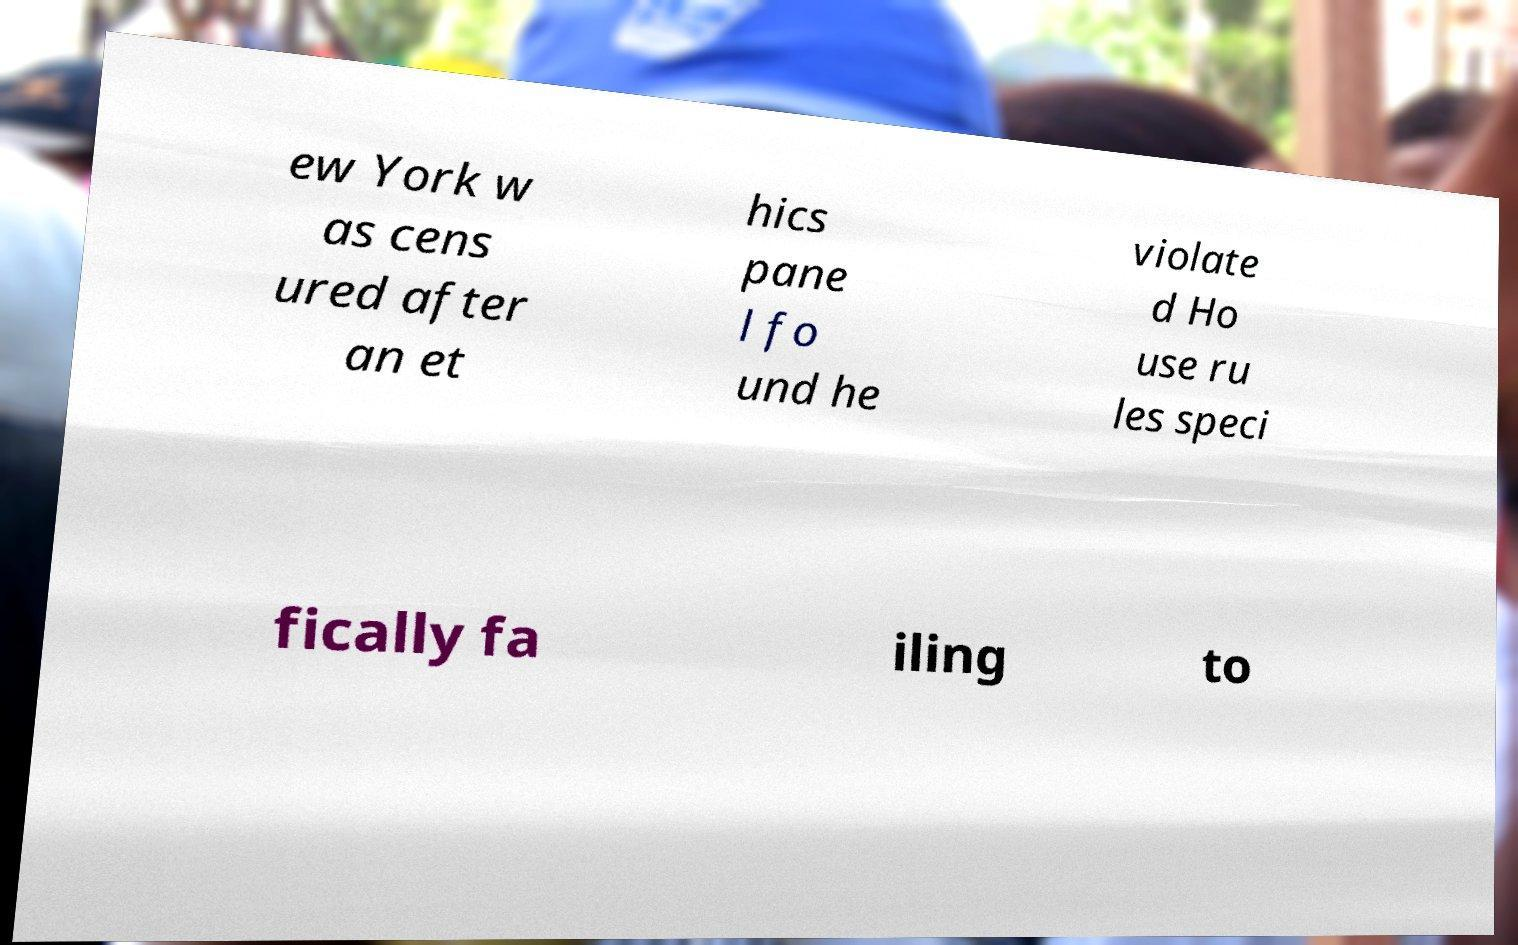Can you accurately transcribe the text from the provided image for me? ew York w as cens ured after an et hics pane l fo und he violate d Ho use ru les speci fically fa iling to 